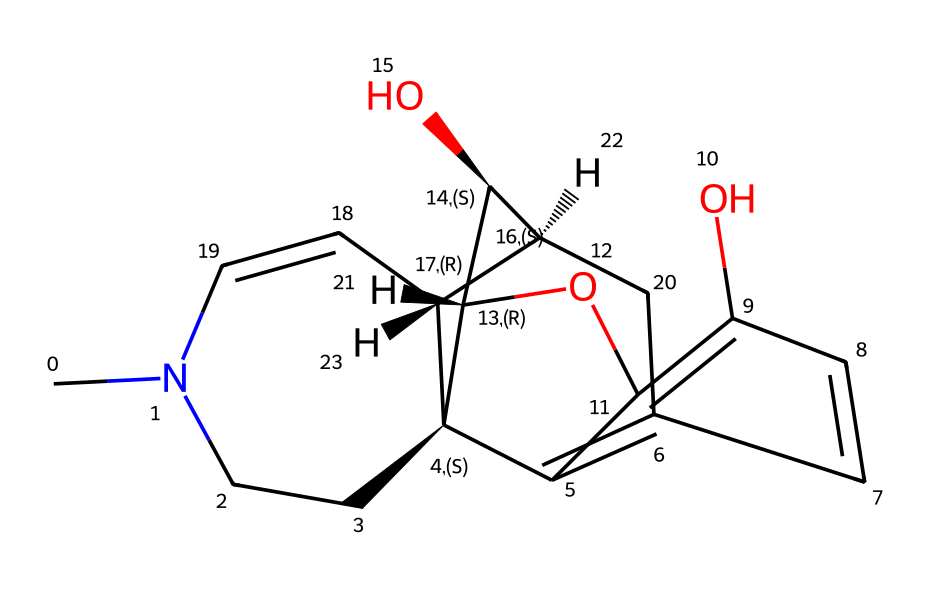What is the molecular formula of morphine? By analyzing the chemical structure derived from the SMILES representation, one can deduce the number of each type of atom present. Counting atoms results in a molecular formula of C17H19NO3.
Answer: C17H19NO3 How many carbon atoms are in the structure? By examining the chemical structure, specifically the segments represented in the SMILES, I can count a total of 17 carbon atoms present in the molecule.
Answer: 17 What type of active site does morphine primarily interact with? Morphine primarily interacts with opioid receptors, which are G-protein-coupled receptors. This classification can be inferred from its molecular structure suggesting its use as a narcotic analgesic.
Answer: opioid receptors How many hydroxyl (-OH) groups are present? Examining the chemical structure for hydroxyl groups, identified by the presence of oxygen and hydrogen atoms, reveals two –OH groups present in the morphine structure.
Answer: 2 What is the stereochemistry of the morphine structure? The SMILES notation indicates multiple stereocenters designated by the "@" symbols. There are four chiral centers identified in morphine's structure based on these specifications.
Answer: 4 What is the primary role of morphine in medicine? Morphine is primarily used for pain relief due to its action on opioid receptors in the central nervous system, which is confirmed through its chemical interaction with these receptors.
Answer: pain relief 